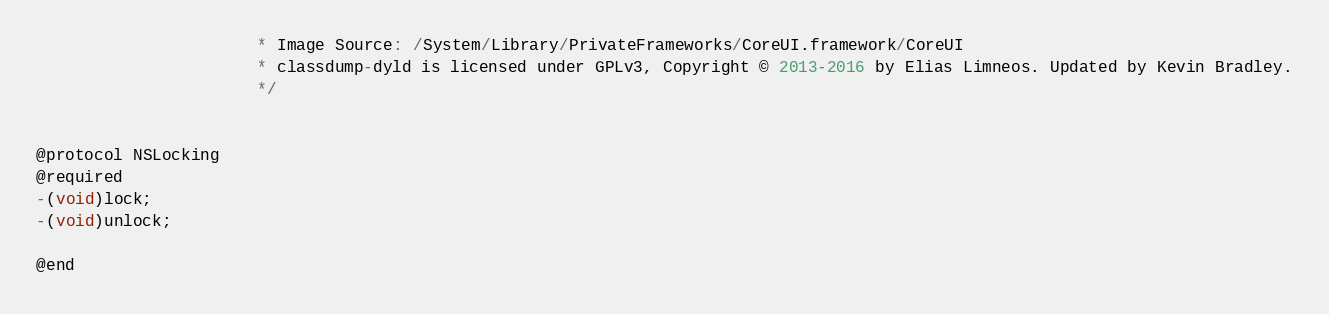<code> <loc_0><loc_0><loc_500><loc_500><_C_>                       * Image Source: /System/Library/PrivateFrameworks/CoreUI.framework/CoreUI
                       * classdump-dyld is licensed under GPLv3, Copyright © 2013-2016 by Elias Limneos. Updated by Kevin Bradley.
                       */


@protocol NSLocking
@required
-(void)lock;
-(void)unlock;

@end

</code> 